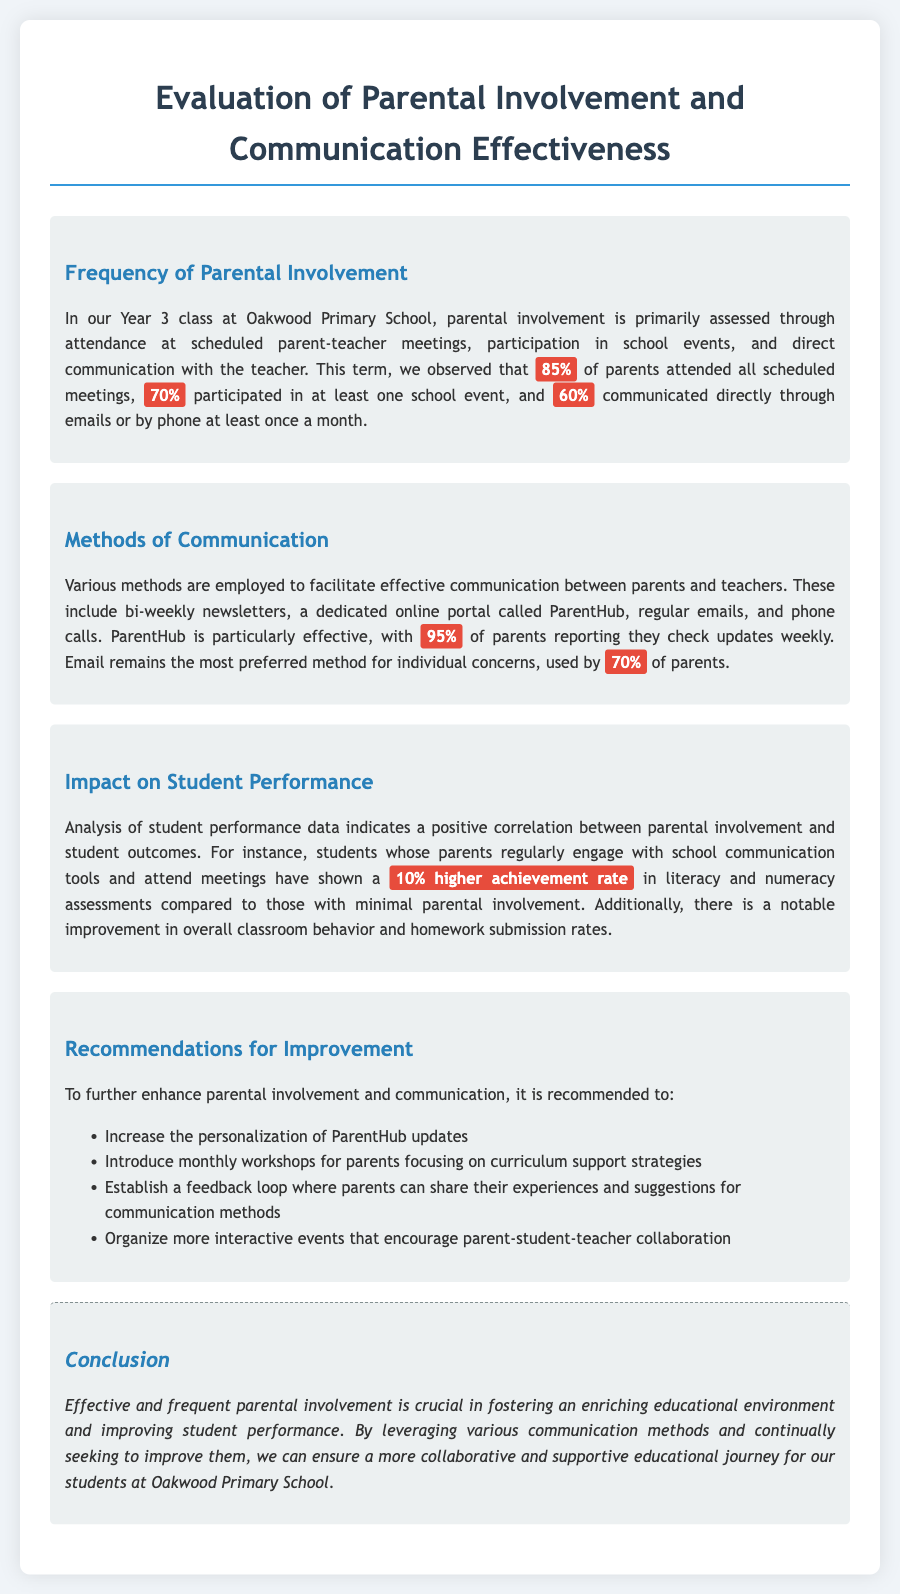What percentage of parents attended all scheduled meetings? This information is provided under the section on Frequency of Parental Involvement, which states that 85% of parents attended all scheduled meetings.
Answer: 85% What is the preferred method of communication for individual concerns? The document states that email remains the most preferred method for individual concerns, used by 70% of parents.
Answer: Email How many parents participated in at least one school event? The section on Frequency of Parental Involvement notes that 70% participated in at least one school event.
Answer: 70% What was the increase in achievement rate for students with engaged parents? The document indicates a 10% higher achievement rate in literacy and numeracy assessments for students whose parents regularly engage.
Answer: 10% Which online portal is mentioned for facilitating communication? The document refers to a dedicated online portal called ParentHub for communication between parents and teachers.
Answer: ParentHub What recommendation is made to enhance parental involvement? The list includes increasing personalization of ParentHub updates as a recommendation to enhance involvement.
Answer: Personalization of ParentHub updates What impact does parental involvement have on student classroom behavior? The document mentions a notable improvement in overall classroom behavior for students with engaged parents.
Answer: Improvement What is the main conclusion of the appraisal document? The conclusion stresses that effective and frequent parental involvement is crucial for fostering an enriching educational environment.
Answer: Parental involvement is crucial 